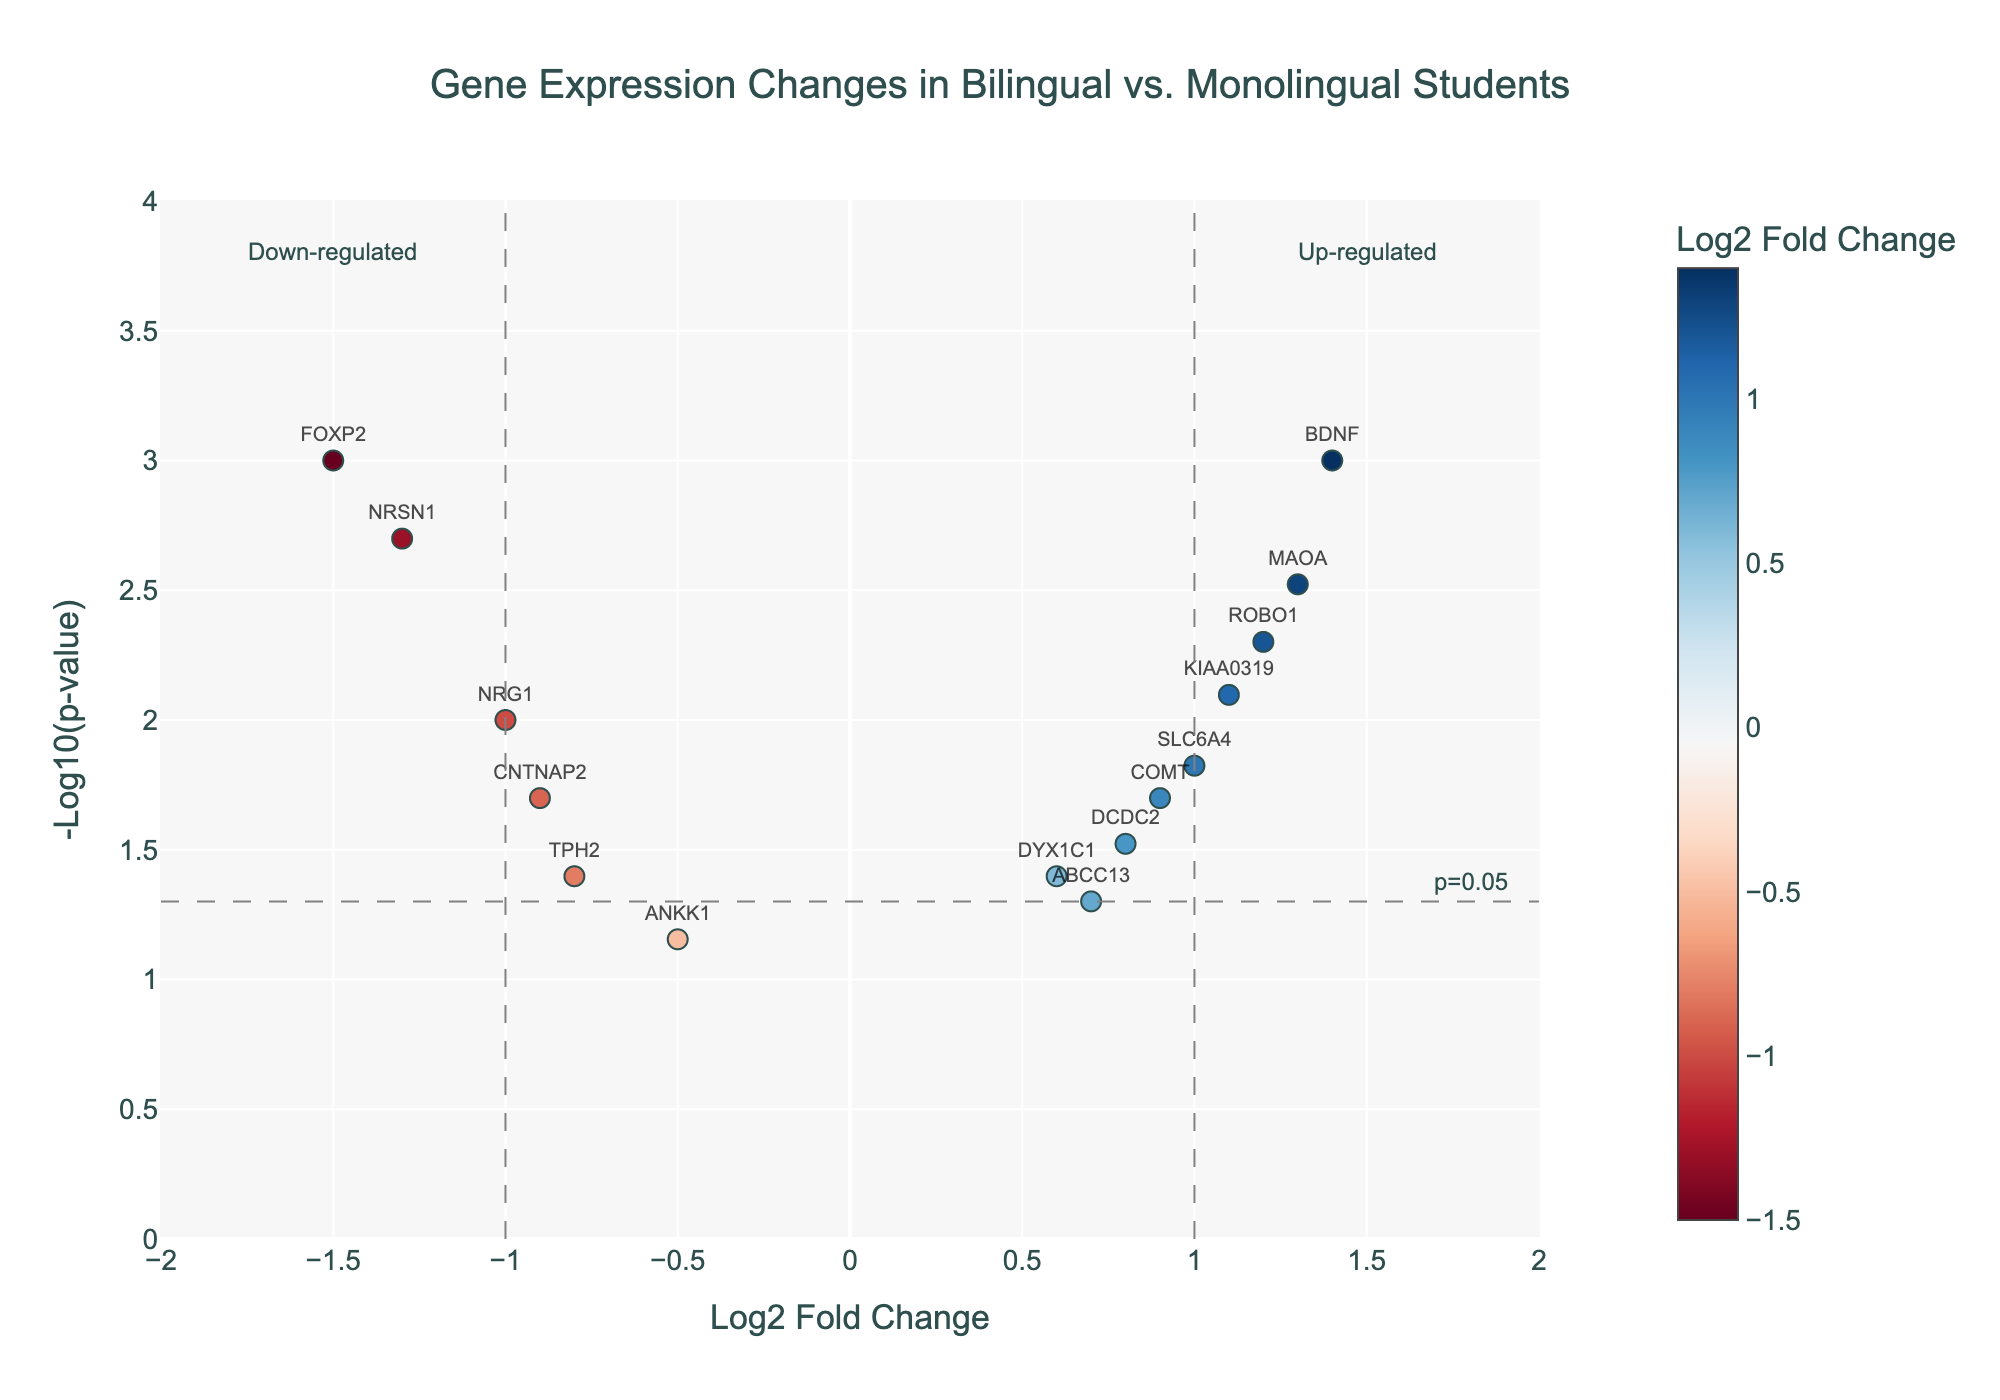What is the title of the figure? The title is displayed at the top center of the figure. It is typically in a larger font size and darker color compared to the rest of the text.
Answer: Gene Expression Changes in Bilingual vs. Monolingual Students How many genes have a negative log2 fold change? To find this, count the data points with a log2 fold change value less than 0. The points colored in respective shades on the left side of the vertical line at 0 are considered.
Answer: 6 Which gene has the highest -log10(p-value)? Locate the data point that reaches the maximum value on the y-axis. Hover over it, or check the largest y-axis value directly and identify the corresponding gene name.
Answer: BDNF How many genes are statistically significant (p-value < 0.05)? See the dashed horizontal line representing the threshold of p=0.05, which corresponds to -log10(p) on the y-axis. Count all the data points above this line.
Answer: 12 What are the names of the up-regulated genes (log2 fold change > 1)? Look to the right of the vertical line at log2 fold change = 1. Identify and list the names of the genes in this region.
Answer: ROBO1, KIAA0319, BDNF, MAOA Which gene is both up-regulated (log2 fold change > 0) and has a p-value < 0.01? Focus on the area of the plot where log2 fold change is greater than 0 and -log10(p) is greater than 2 (p < 0.01). Identify the gene in that intersected region.
Answer: ROBO1, BDNF, MAOA Which gene has the closest log2 fold change to zero? Look for the data point nearest to the vertical line at 0 on the x-axis. Identify the corresponding gene.
Answer: ANKK1 What is the log2 fold change and p-value of the gene FOXP2? Locate the data point labeled as FOXP2. Hovering over it or reading its position on the axes directly will give the log2 fold change and p-value.
Answer: -1.5, 0.001 For the gene COMT, is it up-regulated or down-regulated, and what is the p-value? Find the data point labeled as COMT. Observe its position relative to 0 on the x-axis for up-/down-regulation and check the y-axis for the p-value.
Answer: Up-regulated, 0.02 